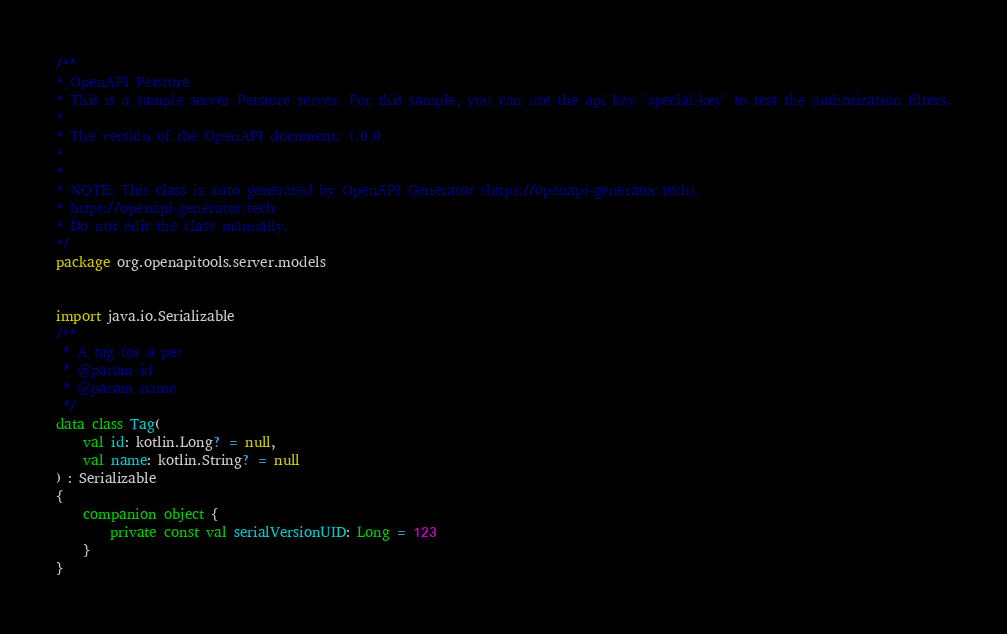Convert code to text. <code><loc_0><loc_0><loc_500><loc_500><_Kotlin_>/**
* OpenAPI Petstore
* This is a sample server Petstore server. For this sample, you can use the api key `special-key` to test the authorization filters.
*
* The version of the OpenAPI document: 1.0.0
* 
*
* NOTE: This class is auto generated by OpenAPI Generator (https://openapi-generator.tech).
* https://openapi-generator.tech
* Do not edit the class manually.
*/
package org.openapitools.server.models


import java.io.Serializable
/**
 * A tag for a pet
 * @param id 
 * @param name 
 */
data class Tag(
    val id: kotlin.Long? = null,
    val name: kotlin.String? = null
) : Serializable 
{
    companion object {
        private const val serialVersionUID: Long = 123
    }
}

</code> 